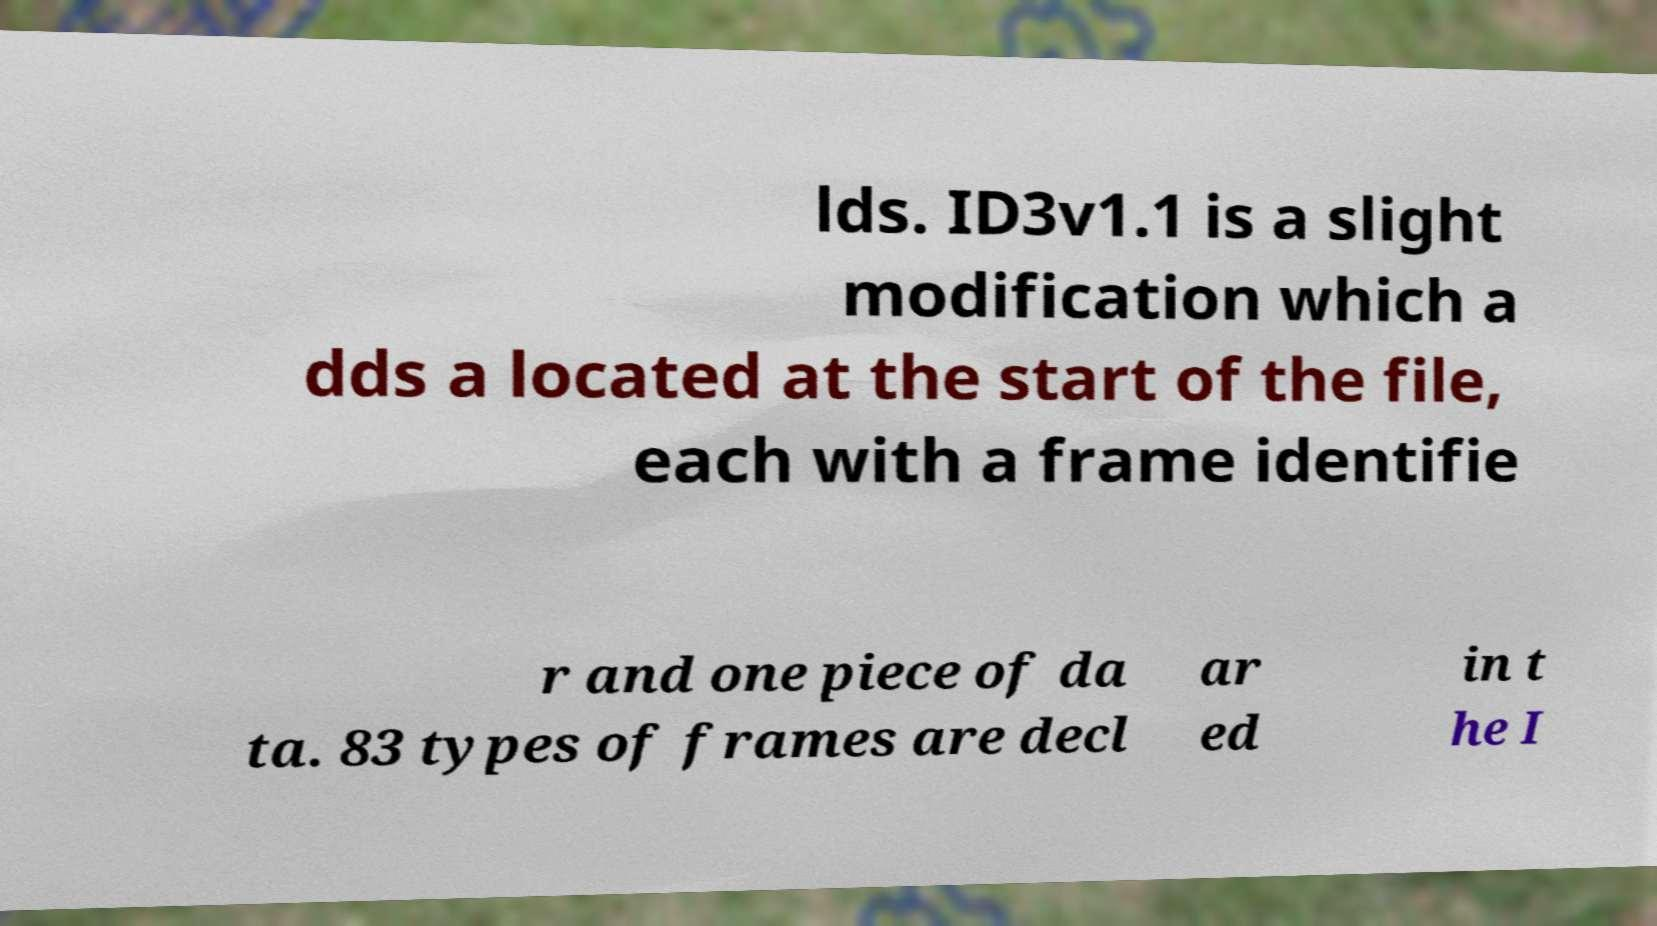Could you extract and type out the text from this image? lds. ID3v1.1 is a slight modification which a dds a located at the start of the file, each with a frame identifie r and one piece of da ta. 83 types of frames are decl ar ed in t he I 